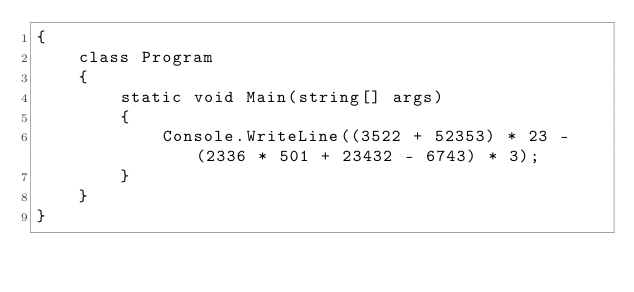<code> <loc_0><loc_0><loc_500><loc_500><_C#_>{
    class Program
    {
        static void Main(string[] args)
        {
            Console.WriteLine((3522 + 52353) * 23 - (2336 * 501 + 23432 - 6743) * 3);
        }
    }
}
</code> 